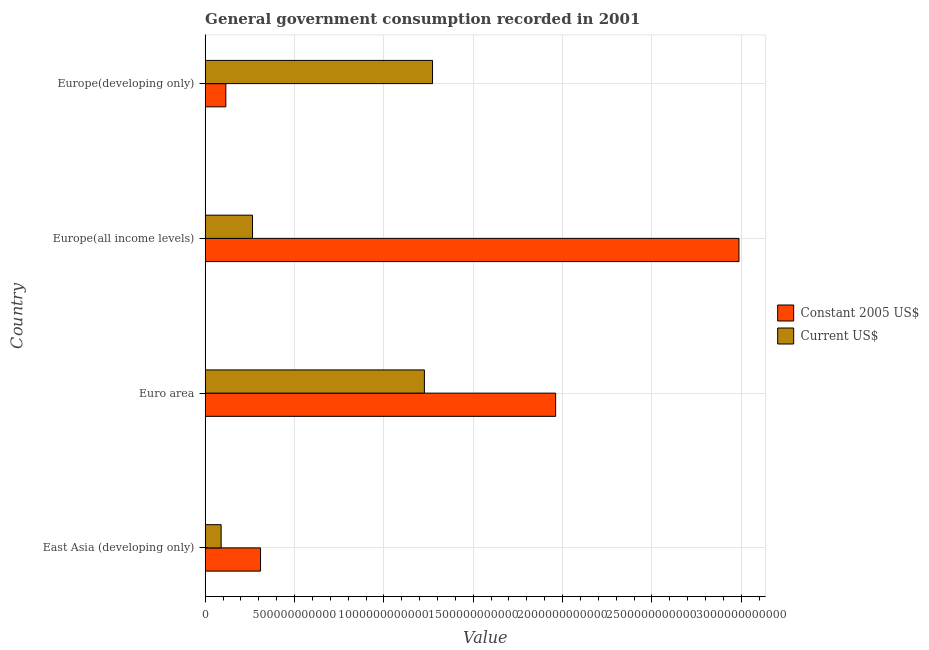How many different coloured bars are there?
Your response must be concise. 2. How many groups of bars are there?
Keep it short and to the point. 4. Are the number of bars per tick equal to the number of legend labels?
Ensure brevity in your answer.  Yes. What is the label of the 1st group of bars from the top?
Make the answer very short. Europe(developing only). What is the value consumed in constant 2005 us$ in Euro area?
Provide a succinct answer. 1.96e+12. Across all countries, what is the maximum value consumed in current us$?
Make the answer very short. 1.27e+12. Across all countries, what is the minimum value consumed in constant 2005 us$?
Provide a short and direct response. 1.16e+11. In which country was the value consumed in current us$ maximum?
Offer a terse response. Europe(developing only). In which country was the value consumed in current us$ minimum?
Your response must be concise. East Asia (developing only). What is the total value consumed in constant 2005 us$ in the graph?
Make the answer very short. 5.37e+12. What is the difference between the value consumed in constant 2005 us$ in Euro area and that in Europe(all income levels)?
Your response must be concise. -1.03e+12. What is the difference between the value consumed in constant 2005 us$ in Europe(all income levels) and the value consumed in current us$ in Euro area?
Provide a short and direct response. 1.76e+12. What is the average value consumed in constant 2005 us$ per country?
Keep it short and to the point. 1.34e+12. What is the difference between the value consumed in current us$ and value consumed in constant 2005 us$ in Euro area?
Your response must be concise. -7.35e+11. What is the ratio of the value consumed in current us$ in Europe(all income levels) to that in Europe(developing only)?
Your response must be concise. 0.21. Is the value consumed in current us$ in East Asia (developing only) less than that in Euro area?
Ensure brevity in your answer.  Yes. Is the difference between the value consumed in constant 2005 us$ in East Asia (developing only) and Europe(all income levels) greater than the difference between the value consumed in current us$ in East Asia (developing only) and Europe(all income levels)?
Your response must be concise. No. What is the difference between the highest and the second highest value consumed in constant 2005 us$?
Your response must be concise. 1.03e+12. What is the difference between the highest and the lowest value consumed in constant 2005 us$?
Offer a very short reply. 2.87e+12. In how many countries, is the value consumed in constant 2005 us$ greater than the average value consumed in constant 2005 us$ taken over all countries?
Offer a terse response. 2. What does the 2nd bar from the top in East Asia (developing only) represents?
Offer a very short reply. Constant 2005 US$. What does the 2nd bar from the bottom in Euro area represents?
Offer a very short reply. Current US$. What is the difference between two consecutive major ticks on the X-axis?
Your answer should be very brief. 5.00e+11. Does the graph contain grids?
Ensure brevity in your answer.  Yes. What is the title of the graph?
Offer a very short reply. General government consumption recorded in 2001. Does "Electricity" appear as one of the legend labels in the graph?
Give a very brief answer. No. What is the label or title of the X-axis?
Offer a very short reply. Value. What is the label or title of the Y-axis?
Provide a short and direct response. Country. What is the Value in Constant 2005 US$ in East Asia (developing only)?
Make the answer very short. 3.10e+11. What is the Value in Current US$ in East Asia (developing only)?
Your answer should be compact. 8.92e+1. What is the Value in Constant 2005 US$ in Euro area?
Give a very brief answer. 1.96e+12. What is the Value in Current US$ in Euro area?
Ensure brevity in your answer.  1.23e+12. What is the Value of Constant 2005 US$ in Europe(all income levels)?
Your answer should be compact. 2.99e+12. What is the Value in Current US$ in Europe(all income levels)?
Your answer should be compact. 2.65e+11. What is the Value of Constant 2005 US$ in Europe(developing only)?
Provide a short and direct response. 1.16e+11. What is the Value of Current US$ in Europe(developing only)?
Your response must be concise. 1.27e+12. Across all countries, what is the maximum Value of Constant 2005 US$?
Your answer should be very brief. 2.99e+12. Across all countries, what is the maximum Value in Current US$?
Your response must be concise. 1.27e+12. Across all countries, what is the minimum Value in Constant 2005 US$?
Give a very brief answer. 1.16e+11. Across all countries, what is the minimum Value in Current US$?
Your answer should be very brief. 8.92e+1. What is the total Value in Constant 2005 US$ in the graph?
Make the answer very short. 5.37e+12. What is the total Value in Current US$ in the graph?
Your answer should be very brief. 2.85e+12. What is the difference between the Value of Constant 2005 US$ in East Asia (developing only) and that in Euro area?
Your answer should be very brief. -1.65e+12. What is the difference between the Value in Current US$ in East Asia (developing only) and that in Euro area?
Provide a succinct answer. -1.14e+12. What is the difference between the Value in Constant 2005 US$ in East Asia (developing only) and that in Europe(all income levels)?
Offer a very short reply. -2.68e+12. What is the difference between the Value of Current US$ in East Asia (developing only) and that in Europe(all income levels)?
Your answer should be compact. -1.76e+11. What is the difference between the Value in Constant 2005 US$ in East Asia (developing only) and that in Europe(developing only)?
Provide a succinct answer. 1.94e+11. What is the difference between the Value of Current US$ in East Asia (developing only) and that in Europe(developing only)?
Offer a very short reply. -1.18e+12. What is the difference between the Value in Constant 2005 US$ in Euro area and that in Europe(all income levels)?
Your response must be concise. -1.03e+12. What is the difference between the Value in Current US$ in Euro area and that in Europe(all income levels)?
Ensure brevity in your answer.  9.62e+11. What is the difference between the Value of Constant 2005 US$ in Euro area and that in Europe(developing only)?
Provide a succinct answer. 1.85e+12. What is the difference between the Value of Current US$ in Euro area and that in Europe(developing only)?
Make the answer very short. -4.55e+1. What is the difference between the Value of Constant 2005 US$ in Europe(all income levels) and that in Europe(developing only)?
Provide a succinct answer. 2.87e+12. What is the difference between the Value in Current US$ in Europe(all income levels) and that in Europe(developing only)?
Provide a short and direct response. -1.01e+12. What is the difference between the Value in Constant 2005 US$ in East Asia (developing only) and the Value in Current US$ in Euro area?
Make the answer very short. -9.17e+11. What is the difference between the Value of Constant 2005 US$ in East Asia (developing only) and the Value of Current US$ in Europe(all income levels)?
Provide a succinct answer. 4.48e+1. What is the difference between the Value in Constant 2005 US$ in East Asia (developing only) and the Value in Current US$ in Europe(developing only)?
Provide a short and direct response. -9.62e+11. What is the difference between the Value of Constant 2005 US$ in Euro area and the Value of Current US$ in Europe(all income levels)?
Ensure brevity in your answer.  1.70e+12. What is the difference between the Value in Constant 2005 US$ in Euro area and the Value in Current US$ in Europe(developing only)?
Provide a short and direct response. 6.89e+11. What is the difference between the Value in Constant 2005 US$ in Europe(all income levels) and the Value in Current US$ in Europe(developing only)?
Keep it short and to the point. 1.72e+12. What is the average Value in Constant 2005 US$ per country?
Keep it short and to the point. 1.34e+12. What is the average Value in Current US$ per country?
Ensure brevity in your answer.  7.13e+11. What is the difference between the Value of Constant 2005 US$ and Value of Current US$ in East Asia (developing only)?
Your response must be concise. 2.21e+11. What is the difference between the Value in Constant 2005 US$ and Value in Current US$ in Euro area?
Your answer should be very brief. 7.35e+11. What is the difference between the Value of Constant 2005 US$ and Value of Current US$ in Europe(all income levels)?
Ensure brevity in your answer.  2.72e+12. What is the difference between the Value in Constant 2005 US$ and Value in Current US$ in Europe(developing only)?
Offer a very short reply. -1.16e+12. What is the ratio of the Value of Constant 2005 US$ in East Asia (developing only) to that in Euro area?
Provide a succinct answer. 0.16. What is the ratio of the Value of Current US$ in East Asia (developing only) to that in Euro area?
Offer a terse response. 0.07. What is the ratio of the Value in Constant 2005 US$ in East Asia (developing only) to that in Europe(all income levels)?
Give a very brief answer. 0.1. What is the ratio of the Value of Current US$ in East Asia (developing only) to that in Europe(all income levels)?
Give a very brief answer. 0.34. What is the ratio of the Value of Constant 2005 US$ in East Asia (developing only) to that in Europe(developing only)?
Offer a terse response. 2.68. What is the ratio of the Value of Current US$ in East Asia (developing only) to that in Europe(developing only)?
Provide a short and direct response. 0.07. What is the ratio of the Value in Constant 2005 US$ in Euro area to that in Europe(all income levels)?
Provide a succinct answer. 0.66. What is the ratio of the Value of Current US$ in Euro area to that in Europe(all income levels)?
Provide a succinct answer. 4.63. What is the ratio of the Value in Constant 2005 US$ in Euro area to that in Europe(developing only)?
Your response must be concise. 16.98. What is the ratio of the Value of Current US$ in Euro area to that in Europe(developing only)?
Your answer should be compact. 0.96. What is the ratio of the Value of Constant 2005 US$ in Europe(all income levels) to that in Europe(developing only)?
Provide a short and direct response. 25.86. What is the ratio of the Value in Current US$ in Europe(all income levels) to that in Europe(developing only)?
Your response must be concise. 0.21. What is the difference between the highest and the second highest Value of Constant 2005 US$?
Give a very brief answer. 1.03e+12. What is the difference between the highest and the second highest Value of Current US$?
Provide a succinct answer. 4.55e+1. What is the difference between the highest and the lowest Value of Constant 2005 US$?
Keep it short and to the point. 2.87e+12. What is the difference between the highest and the lowest Value in Current US$?
Provide a short and direct response. 1.18e+12. 